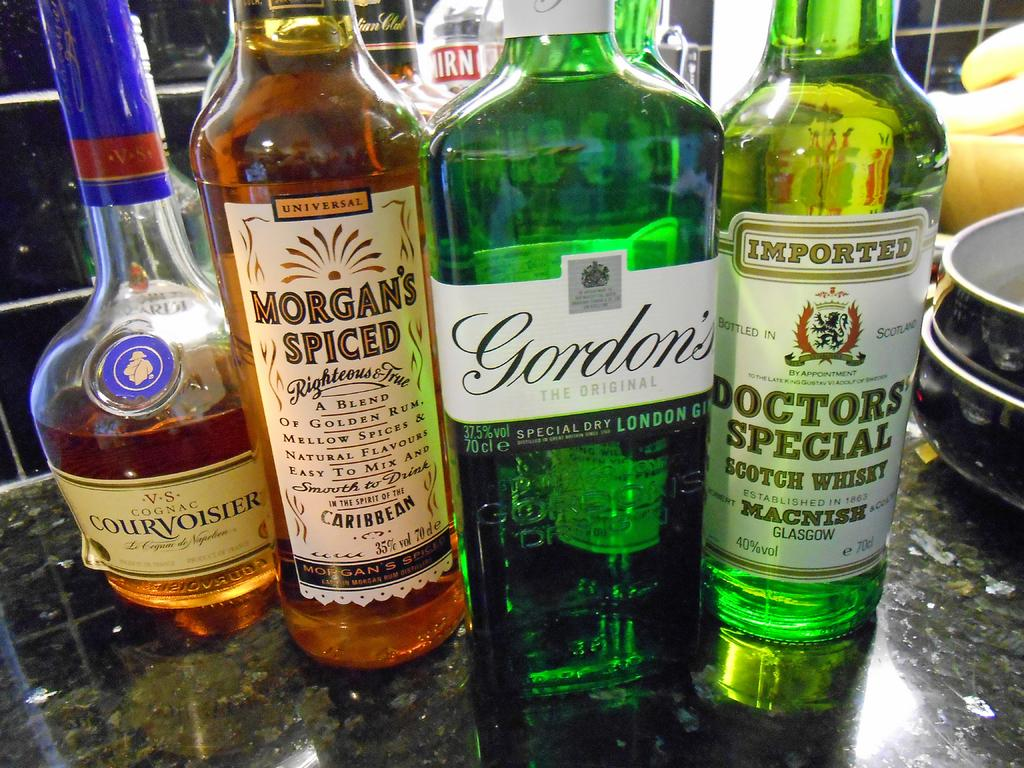<image>
Write a terse but informative summary of the picture. Four bottles of liquor, one of which is Gordon's. 